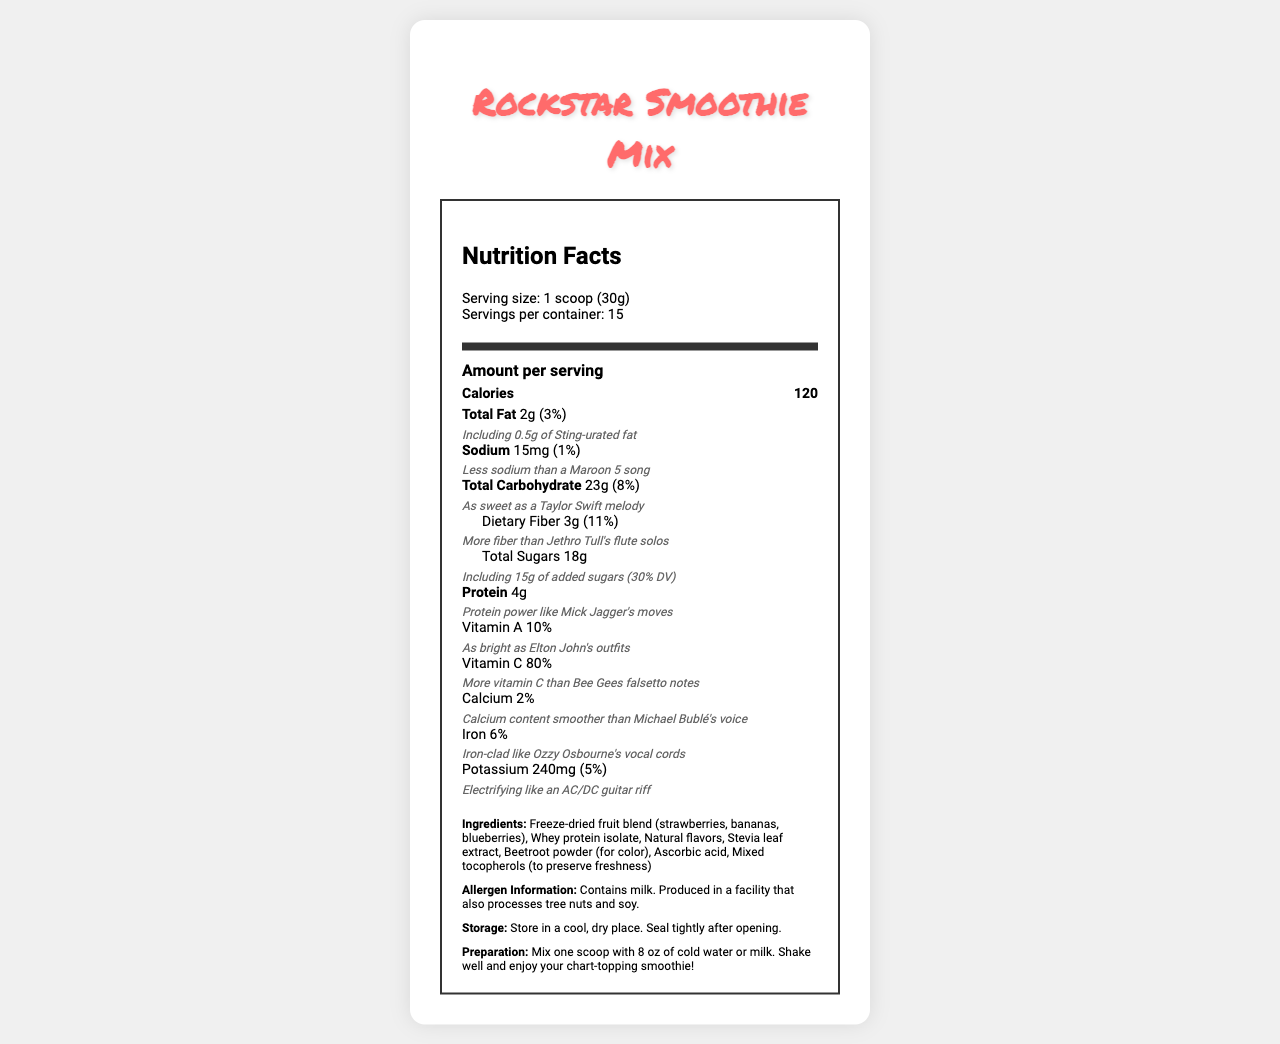what is the serving size? The serving size is clearly mentioned under the heading "Serving size" in the document.
Answer: 1 scoop (30g) how many servings per container? The number of servings per container is stated under the heading "Servings per container."
Answer: 15 how many calories are in one serving? The number of calories per serving is listed as 120 under the heading "Calories."
Answer: 120 what is the amount of total fat per serving? The amount of total fat per serving is 2g, which is 3% of the daily value, as mentioned under "Total Fat."
Answer: 2g (3% DV) who is the nutritional power of protein compared to? The note under the protein amount mentions that the protein power is "like Mick Jagger's moves."
Answer: Mick Jagger's moves what is the daily value of vitamin C per serving? The daily value of vitamin C per serving is indicated as 80% in the document.
Answer: 80% what is the note associated with sodium content? The note for sodium content indicates it has "Less sodium than a Maroon 5 song."
Answer: Less sodium than a Maroon 5 song what are the main ingredients in this product? The main ingredients are listed clearly under the Ingredients section.
Answer: Freeze-dried fruit blend (strawberries, bananas, blueberries), Whey protein isolate, Natural flavors, Stevia leaf extract, Beetroot powder (for color), Ascorbic acid, Mixed tocopherols (to preserve freshness) does this product contain any added sugars? (Yes/No) The document specifies that it includes 15g of added sugars, noting "Including 15g of added sugars (30% DV)."
Answer: Yes from what musicians is the beverage's calcium content compared to? The calcium content is described as being "smoother than Michael Bublé's voice" in the note.
Answer: Michael Bublé's voice where should you store this product? The storage instructions are detailed at the bottom of the document.
Answer: Store in a cool, dry place. Seal tightly after opening. how should you prepare this smoothie mix? The preparation instructions are detailed at the bottom of the document.
Answer: Mix one scoop with 8 oz of cold water or milk. Shake well and enjoy your chart-topping smoothie! how does the vitamin A content compare to musician references? The note under vitamin A indicates it's "As bright as Elton John's outfits."
Answer: As bright as Elton John's outfits what is the percentage of daily value for dietary fiber? The daily value for dietary fiber per serving is indicated as 11%.
Answer: 11% calculate the total amount of sugars per container Each serving contains 18g of sugar. Given there are 15 servings per container, the total sugar is 15 servings * 18g = 270g.
Answer: 270g which nutrient comparison note is associated with the element potassium? A. Less sodium than a Maroon 5 song B. More fiber than Jethro Tull's flute solos C. Electrifying like an AC/DC guitar riff D. Protein power like Mick Jagger's moves The note for potassium in the document is "Electrifying like an AC/DC guitar riff."
Answer: C what percentage of daily iron does one serving of the smoothie mix provide? The daily value of iron per serving is specified as 6%.
Answer: 6% compare the total carbohydrate content to artist references. A. Mick Jagger's moves B. Maroon 5's song C. A Taylor Swift melody D. Bee Gees falsetto notes The note under total carbohydrate mentions it's "As sweet as a Taylor Swift melody."
Answer: C what is the daily value percentage of calcium per serving? A. 2% B. 5% C. 6% D. 10% The daily value of calcium per serving is given as 2%.
Answer: A can you determine the price of the product from the document? The document does not provide any pricing information.
Answer: Not enough information describe the main idea of the document. The document is a label for "Rockstar Smoothie Mix," presenting detailed nutritional facts and fun comparisons to musicians, making it informative and engaging for consumers.
Answer: The document provides the nutritional facts for "Rockstar Smoothie Mix," featuring servings per container, serving size, calorie count, and detailed nutrient information with musician-themed comparison notes. It also includes ingredients, allergen information, storage, and preparation instructions. 